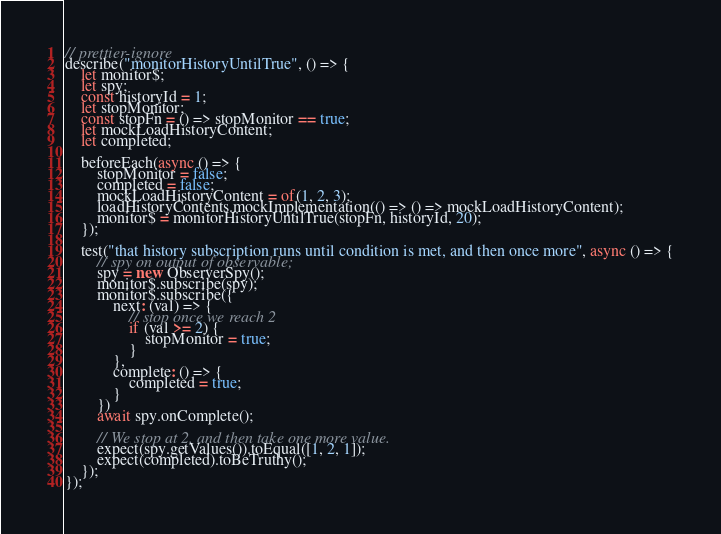<code> <loc_0><loc_0><loc_500><loc_500><_JavaScript_>
// prettier-ignore
describe("monitorHistoryUntilTrue", () => {
    let monitor$;
    let spy;
    const historyId = 1;
    let stopMonitor;
    const stopFn = () => stopMonitor == true;
    let mockLoadHistoryContent;
    let completed;

    beforeEach(async () => {
        stopMonitor = false;
        completed = false;
        mockLoadHistoryContent = of(1, 2, 3);
        loadHistoryContents.mockImplementation(() => () => mockLoadHistoryContent);
        monitor$ = monitorHistoryUntilTrue(stopFn, historyId, 20);
    });

    test("that history subscription runs until condition is met, and then once more", async () => {
        // spy on output of observable;
        spy = new ObserverSpy();
        monitor$.subscribe(spy);
        monitor$.subscribe({
            next: (val) => {
                // stop once we reach 2
                if (val >= 2) {
                    stopMonitor = true;
                }
            },
            complete: () => {
                completed = true;
            }
        })
        await spy.onComplete();

        // We stop at 2, and then take one more value.
        expect(spy.getValues()).toEqual([1, 2, 1]);
        expect(completed).toBeTruthy();
    });
});
</code> 